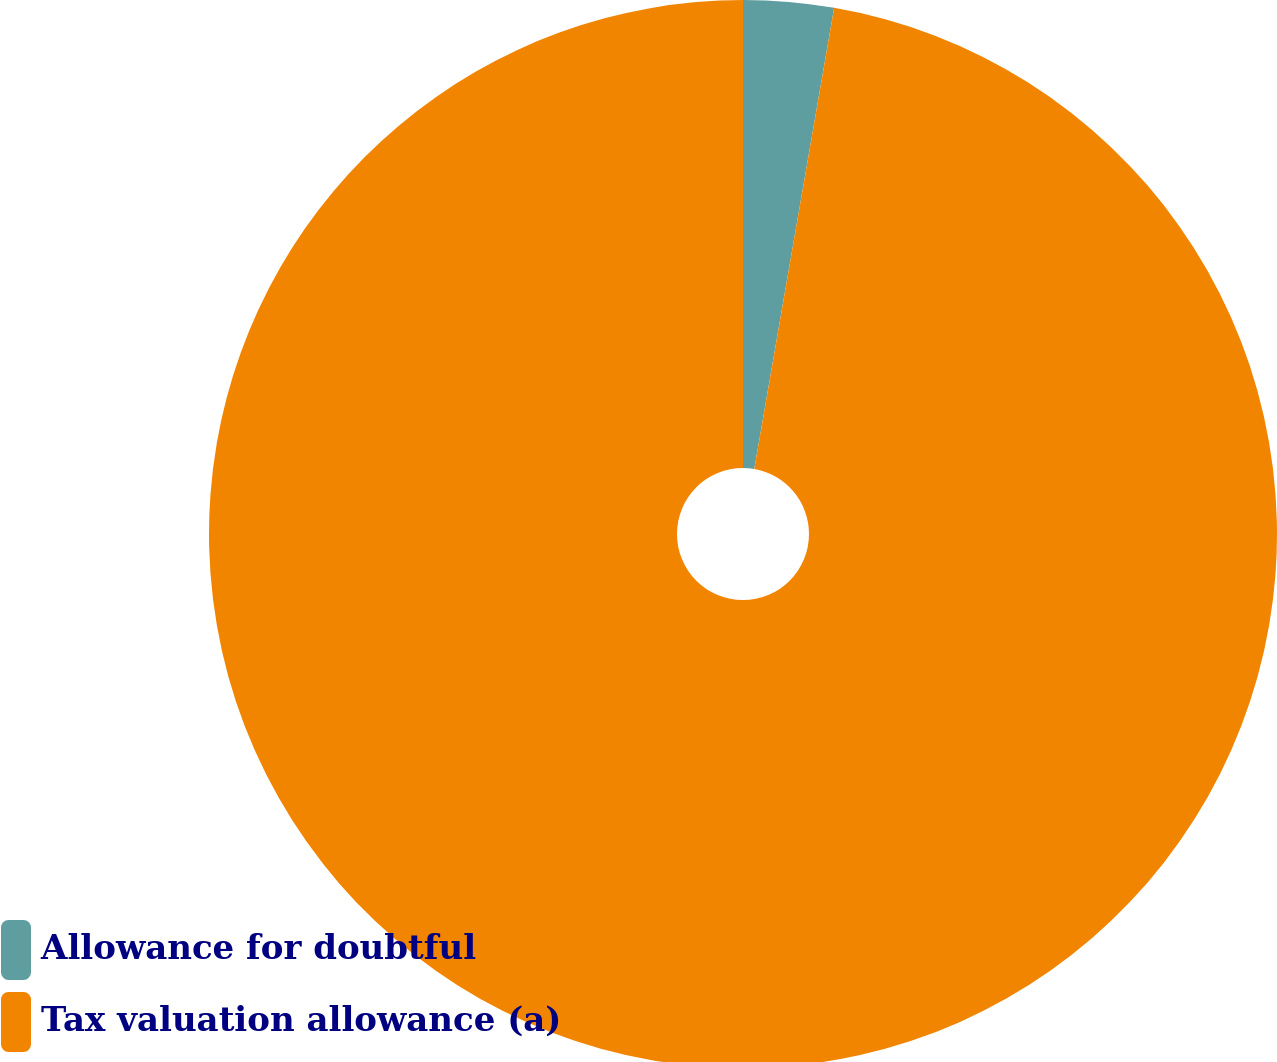<chart> <loc_0><loc_0><loc_500><loc_500><pie_chart><fcel>Allowance for doubtful<fcel>Tax valuation allowance (a)<nl><fcel>2.73%<fcel>97.27%<nl></chart> 